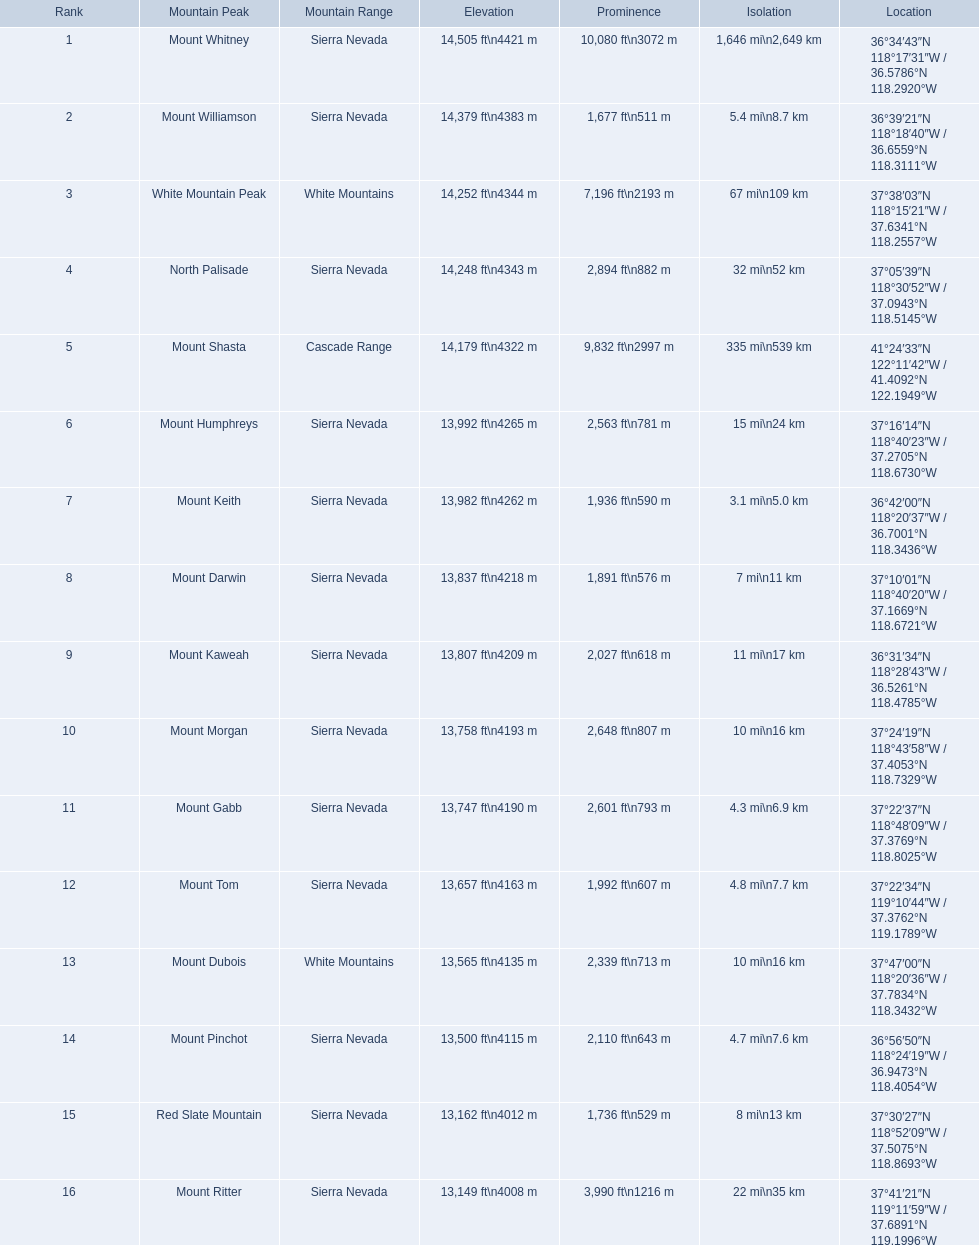What mountain peak is listed for the sierra nevada mountain range? Mount Whitney. What mountain peak has an elevation of 14,379ft? Mount Williamson. Which mountain is listed for the cascade range? Mount Shasta. 